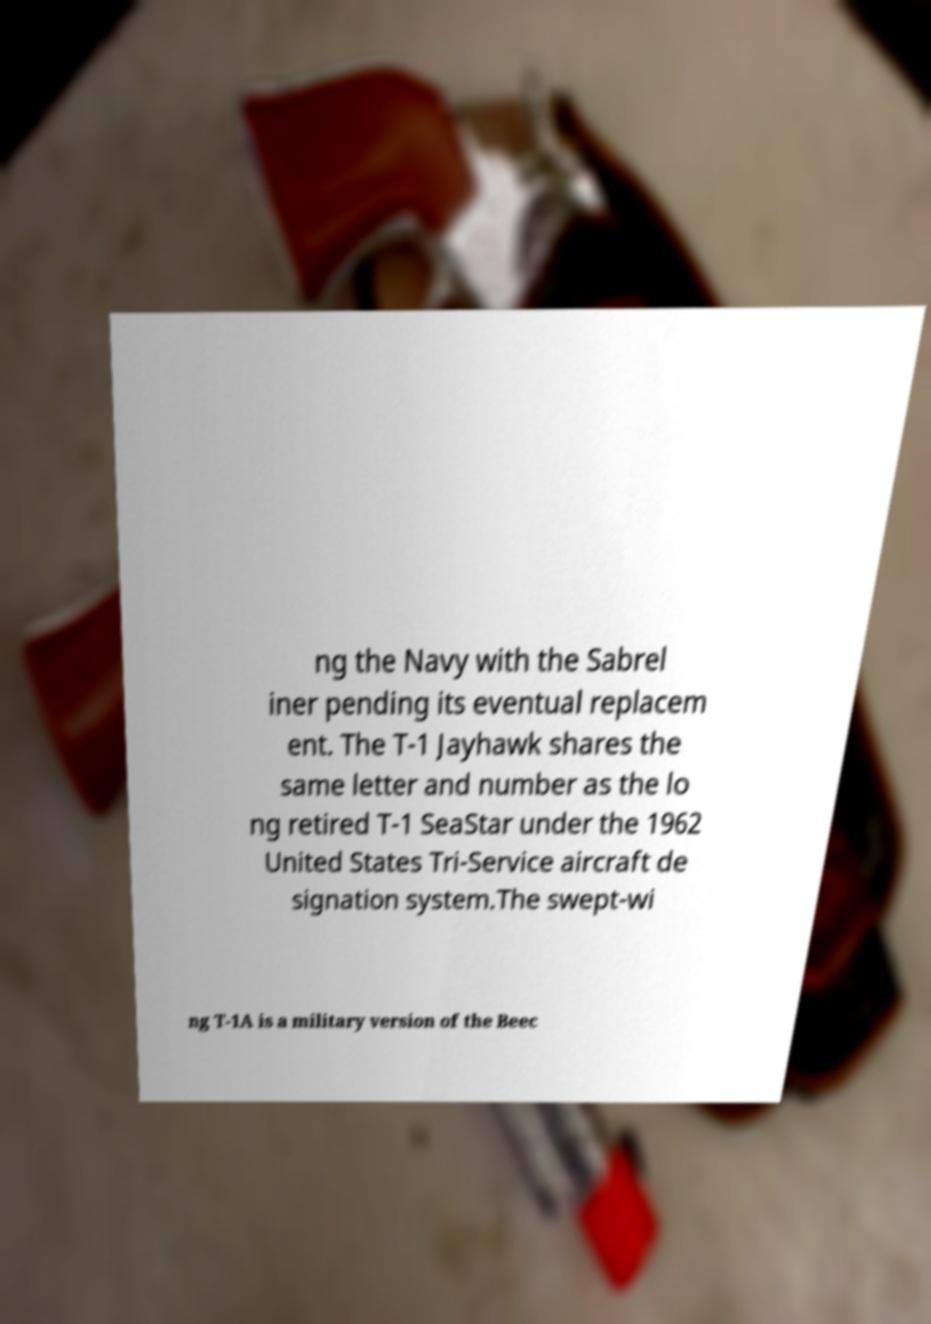I need the written content from this picture converted into text. Can you do that? ng the Navy with the Sabrel iner pending its eventual replacem ent. The T-1 Jayhawk shares the same letter and number as the lo ng retired T-1 SeaStar under the 1962 United States Tri-Service aircraft de signation system.The swept-wi ng T-1A is a military version of the Beec 